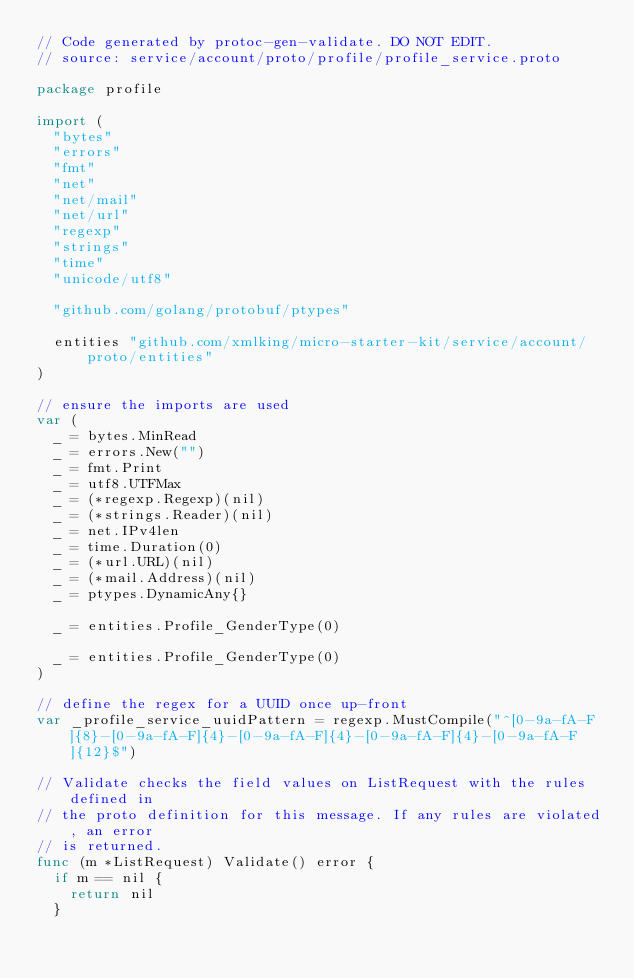<code> <loc_0><loc_0><loc_500><loc_500><_Go_>// Code generated by protoc-gen-validate. DO NOT EDIT.
// source: service/account/proto/profile/profile_service.proto

package profile

import (
	"bytes"
	"errors"
	"fmt"
	"net"
	"net/mail"
	"net/url"
	"regexp"
	"strings"
	"time"
	"unicode/utf8"

	"github.com/golang/protobuf/ptypes"

	entities "github.com/xmlking/micro-starter-kit/service/account/proto/entities"
)

// ensure the imports are used
var (
	_ = bytes.MinRead
	_ = errors.New("")
	_ = fmt.Print
	_ = utf8.UTFMax
	_ = (*regexp.Regexp)(nil)
	_ = (*strings.Reader)(nil)
	_ = net.IPv4len
	_ = time.Duration(0)
	_ = (*url.URL)(nil)
	_ = (*mail.Address)(nil)
	_ = ptypes.DynamicAny{}

	_ = entities.Profile_GenderType(0)

	_ = entities.Profile_GenderType(0)
)

// define the regex for a UUID once up-front
var _profile_service_uuidPattern = regexp.MustCompile("^[0-9a-fA-F]{8}-[0-9a-fA-F]{4}-[0-9a-fA-F]{4}-[0-9a-fA-F]{4}-[0-9a-fA-F]{12}$")

// Validate checks the field values on ListRequest with the rules defined in
// the proto definition for this message. If any rules are violated, an error
// is returned.
func (m *ListRequest) Validate() error {
	if m == nil {
		return nil
	}
</code> 